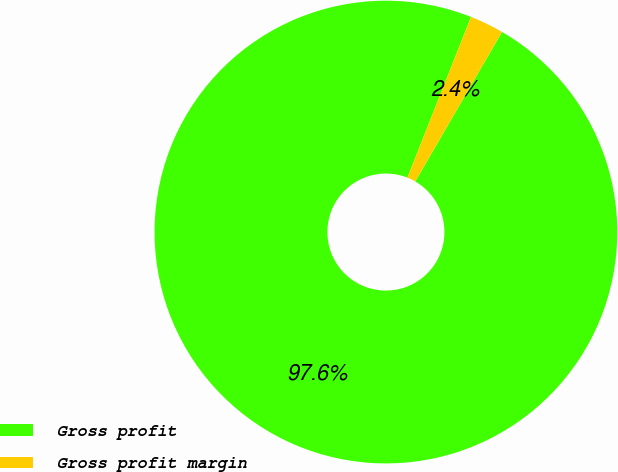Convert chart to OTSL. <chart><loc_0><loc_0><loc_500><loc_500><pie_chart><fcel>Gross profit<fcel>Gross profit margin<nl><fcel>97.63%<fcel>2.37%<nl></chart> 